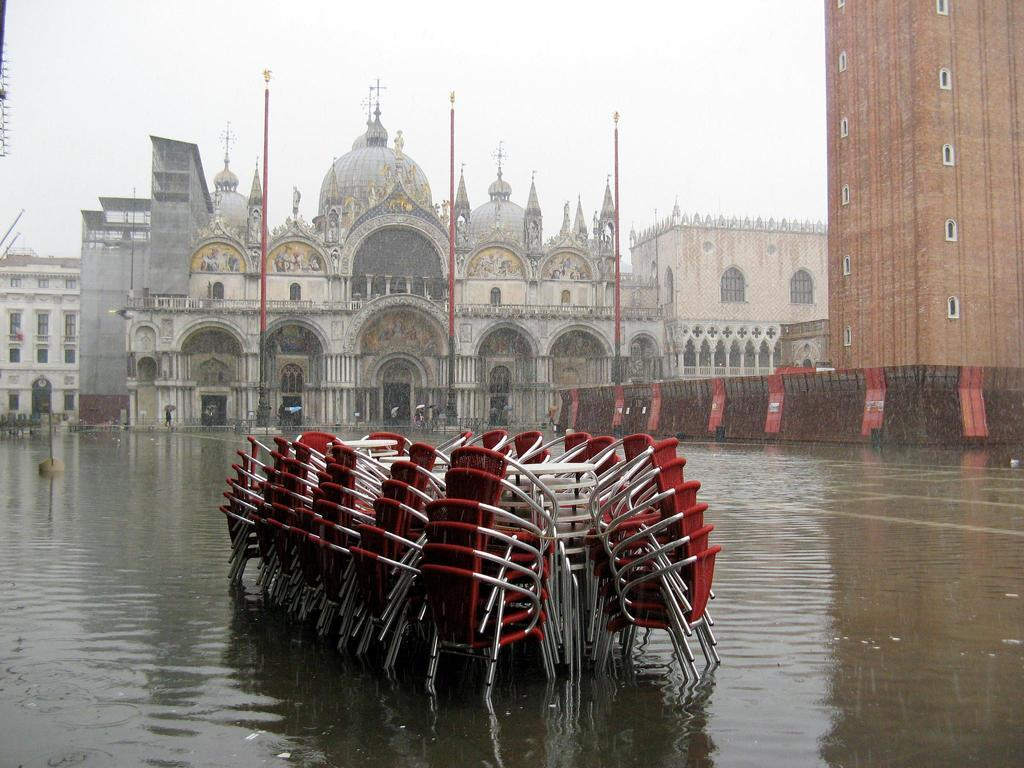What type of structures can be seen in the image? There are buildings in the image. What else is present in the image besides buildings? There are poles and chairs in the water visible in the image. How would you describe the sky in the image? The sky is cloudy in the image. How many zippers can be seen on the buildings in the image? There are no zippers present on the buildings in the image. What type of birds can be seen flying in the image? There are no birds visible in the image. 